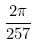Convert formula to latex. <formula><loc_0><loc_0><loc_500><loc_500>\frac { 2 \pi } { 2 5 7 }</formula> 